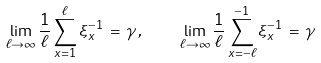<formula> <loc_0><loc_0><loc_500><loc_500>\lim _ { \ell \to \infty } \frac { 1 } { \ell } \sum _ { x = 1 } ^ { \ell } \xi _ { x } ^ { - 1 } \, = \, \gamma \, , \quad \lim _ { \ell \to \infty } \frac { 1 } { \ell } \sum _ { x = - \ell } ^ { - 1 } \xi _ { x } ^ { - 1 } \, = \, \gamma</formula> 